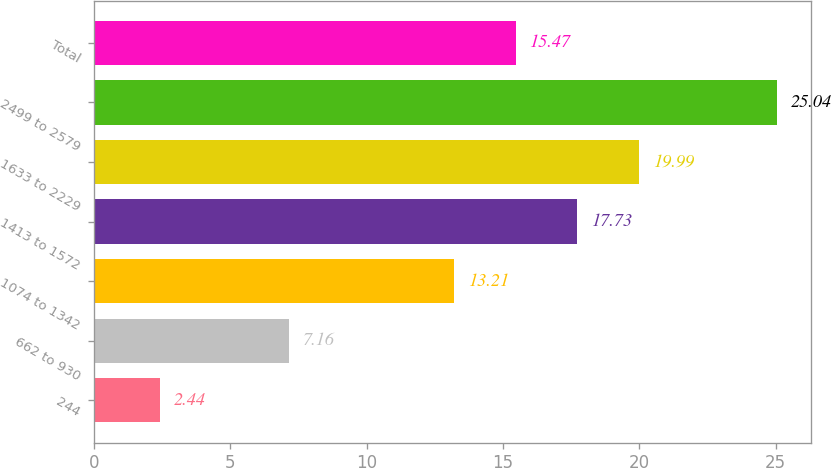<chart> <loc_0><loc_0><loc_500><loc_500><bar_chart><fcel>244<fcel>662 to 930<fcel>1074 to 1342<fcel>1413 to 1572<fcel>1633 to 2229<fcel>2499 to 2579<fcel>Total<nl><fcel>2.44<fcel>7.16<fcel>13.21<fcel>17.73<fcel>19.99<fcel>25.04<fcel>15.47<nl></chart> 